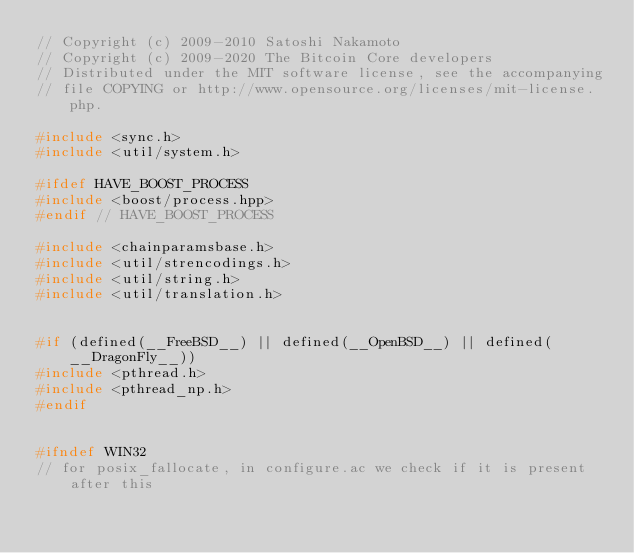Convert code to text. <code><loc_0><loc_0><loc_500><loc_500><_C++_>// Copyright (c) 2009-2010 Satoshi Nakamoto
// Copyright (c) 2009-2020 The Bitcoin Core developers
// Distributed under the MIT software license, see the accompanying
// file COPYING or http://www.opensource.org/licenses/mit-license.php.

#include <sync.h>
#include <util/system.h>

#ifdef HAVE_BOOST_PROCESS
#include <boost/process.hpp>
#endif // HAVE_BOOST_PROCESS

#include <chainparamsbase.h>
#include <util/strencodings.h>
#include <util/string.h>
#include <util/translation.h>


#if (defined(__FreeBSD__) || defined(__OpenBSD__) || defined(__DragonFly__))
#include <pthread.h>
#include <pthread_np.h>
#endif


#ifndef WIN32
// for posix_fallocate, in configure.ac we check if it is present after this</code> 